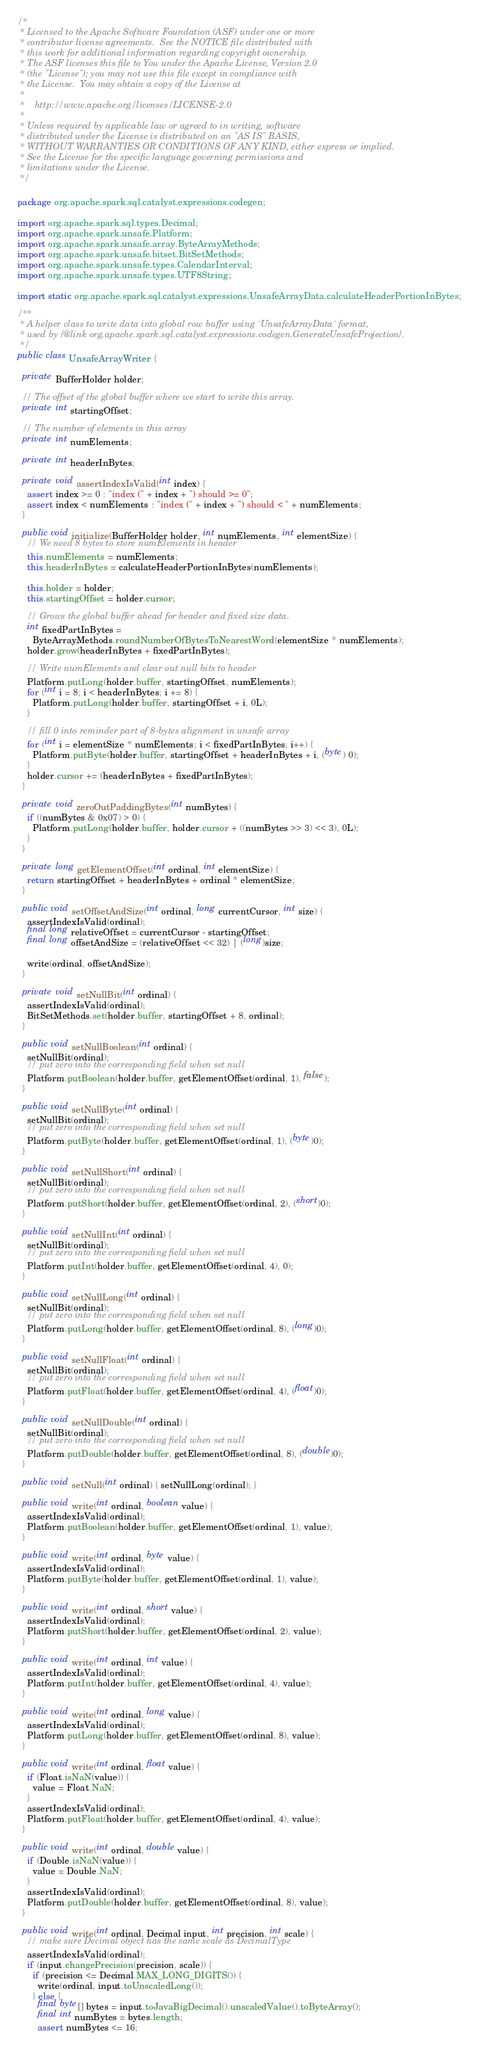Convert code to text. <code><loc_0><loc_0><loc_500><loc_500><_Java_>/*
 * Licensed to the Apache Software Foundation (ASF) under one or more
 * contributor license agreements.  See the NOTICE file distributed with
 * this work for additional information regarding copyright ownership.
 * The ASF licenses this file to You under the Apache License, Version 2.0
 * (the "License"); you may not use this file except in compliance with
 * the License.  You may obtain a copy of the License at
 *
 *    http://www.apache.org/licenses/LICENSE-2.0
 *
 * Unless required by applicable law or agreed to in writing, software
 * distributed under the License is distributed on an "AS IS" BASIS,
 * WITHOUT WARRANTIES OR CONDITIONS OF ANY KIND, either express or implied.
 * See the License for the specific language governing permissions and
 * limitations under the License.
 */

package org.apache.spark.sql.catalyst.expressions.codegen;

import org.apache.spark.sql.types.Decimal;
import org.apache.spark.unsafe.Platform;
import org.apache.spark.unsafe.array.ByteArrayMethods;
import org.apache.spark.unsafe.bitset.BitSetMethods;
import org.apache.spark.unsafe.types.CalendarInterval;
import org.apache.spark.unsafe.types.UTF8String;

import static org.apache.spark.sql.catalyst.expressions.UnsafeArrayData.calculateHeaderPortionInBytes;

/**
 * A helper class to write data into global row buffer using `UnsafeArrayData` format,
 * used by {@link org.apache.spark.sql.catalyst.expressions.codegen.GenerateUnsafeProjection}.
 */
public class UnsafeArrayWriter {

  private BufferHolder holder;

  // The offset of the global buffer where we start to write this array.
  private int startingOffset;

  // The number of elements in this array
  private int numElements;

  private int headerInBytes;

  private void assertIndexIsValid(int index) {
    assert index >= 0 : "index (" + index + ") should >= 0";
    assert index < numElements : "index (" + index + ") should < " + numElements;
  }

  public void initialize(BufferHolder holder, int numElements, int elementSize) {
    // We need 8 bytes to store numElements in header
    this.numElements = numElements;
    this.headerInBytes = calculateHeaderPortionInBytes(numElements);

    this.holder = holder;
    this.startingOffset = holder.cursor;

    // Grows the global buffer ahead for header and fixed size data.
    int fixedPartInBytes =
      ByteArrayMethods.roundNumberOfBytesToNearestWord(elementSize * numElements);
    holder.grow(headerInBytes + fixedPartInBytes);

    // Write numElements and clear out null bits to header
    Platform.putLong(holder.buffer, startingOffset, numElements);
    for (int i = 8; i < headerInBytes; i += 8) {
      Platform.putLong(holder.buffer, startingOffset + i, 0L);
    }

    // fill 0 into reminder part of 8-bytes alignment in unsafe array
    for (int i = elementSize * numElements; i < fixedPartInBytes; i++) {
      Platform.putByte(holder.buffer, startingOffset + headerInBytes + i, (byte) 0);
    }
    holder.cursor += (headerInBytes + fixedPartInBytes);
  }

  private void zeroOutPaddingBytes(int numBytes) {
    if ((numBytes & 0x07) > 0) {
      Platform.putLong(holder.buffer, holder.cursor + ((numBytes >> 3) << 3), 0L);
    }
  }

  private long getElementOffset(int ordinal, int elementSize) {
    return startingOffset + headerInBytes + ordinal * elementSize;
  }

  public void setOffsetAndSize(int ordinal, long currentCursor, int size) {
    assertIndexIsValid(ordinal);
    final long relativeOffset = currentCursor - startingOffset;
    final long offsetAndSize = (relativeOffset << 32) | (long)size;

    write(ordinal, offsetAndSize);
  }

  private void setNullBit(int ordinal) {
    assertIndexIsValid(ordinal);
    BitSetMethods.set(holder.buffer, startingOffset + 8, ordinal);
  }

  public void setNullBoolean(int ordinal) {
    setNullBit(ordinal);
    // put zero into the corresponding field when set null
    Platform.putBoolean(holder.buffer, getElementOffset(ordinal, 1), false);
  }

  public void setNullByte(int ordinal) {
    setNullBit(ordinal);
    // put zero into the corresponding field when set null
    Platform.putByte(holder.buffer, getElementOffset(ordinal, 1), (byte)0);
  }

  public void setNullShort(int ordinal) {
    setNullBit(ordinal);
    // put zero into the corresponding field when set null
    Platform.putShort(holder.buffer, getElementOffset(ordinal, 2), (short)0);
  }

  public void setNullInt(int ordinal) {
    setNullBit(ordinal);
    // put zero into the corresponding field when set null
    Platform.putInt(holder.buffer, getElementOffset(ordinal, 4), 0);
  }

  public void setNullLong(int ordinal) {
    setNullBit(ordinal);
    // put zero into the corresponding field when set null
    Platform.putLong(holder.buffer, getElementOffset(ordinal, 8), (long)0);
  }

  public void setNullFloat(int ordinal) {
    setNullBit(ordinal);
    // put zero into the corresponding field when set null
    Platform.putFloat(holder.buffer, getElementOffset(ordinal, 4), (float)0);
  }

  public void setNullDouble(int ordinal) {
    setNullBit(ordinal);
    // put zero into the corresponding field when set null
    Platform.putDouble(holder.buffer, getElementOffset(ordinal, 8), (double)0);
  }

  public void setNull(int ordinal) { setNullLong(ordinal); }

  public void write(int ordinal, boolean value) {
    assertIndexIsValid(ordinal);
    Platform.putBoolean(holder.buffer, getElementOffset(ordinal, 1), value);
  }

  public void write(int ordinal, byte value) {
    assertIndexIsValid(ordinal);
    Platform.putByte(holder.buffer, getElementOffset(ordinal, 1), value);
  }

  public void write(int ordinal, short value) {
    assertIndexIsValid(ordinal);
    Platform.putShort(holder.buffer, getElementOffset(ordinal, 2), value);
  }

  public void write(int ordinal, int value) {
    assertIndexIsValid(ordinal);
    Platform.putInt(holder.buffer, getElementOffset(ordinal, 4), value);
  }

  public void write(int ordinal, long value) {
    assertIndexIsValid(ordinal);
    Platform.putLong(holder.buffer, getElementOffset(ordinal, 8), value);
  }

  public void write(int ordinal, float value) {
    if (Float.isNaN(value)) {
      value = Float.NaN;
    }
    assertIndexIsValid(ordinal);
    Platform.putFloat(holder.buffer, getElementOffset(ordinal, 4), value);
  }

  public void write(int ordinal, double value) {
    if (Double.isNaN(value)) {
      value = Double.NaN;
    }
    assertIndexIsValid(ordinal);
    Platform.putDouble(holder.buffer, getElementOffset(ordinal, 8), value);
  }

  public void write(int ordinal, Decimal input, int precision, int scale) {
    // make sure Decimal object has the same scale as DecimalType
    assertIndexIsValid(ordinal);
    if (input.changePrecision(precision, scale)) {
      if (precision <= Decimal.MAX_LONG_DIGITS()) {
        write(ordinal, input.toUnscaledLong());
      } else {
        final byte[] bytes = input.toJavaBigDecimal().unscaledValue().toByteArray();
        final int numBytes = bytes.length;
        assert numBytes <= 16;</code> 